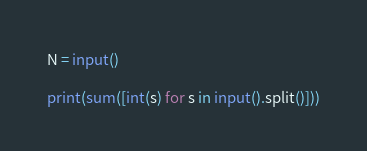<code> <loc_0><loc_0><loc_500><loc_500><_Python_>N = input()

print(sum([int(s) for s in input().split()]))</code> 